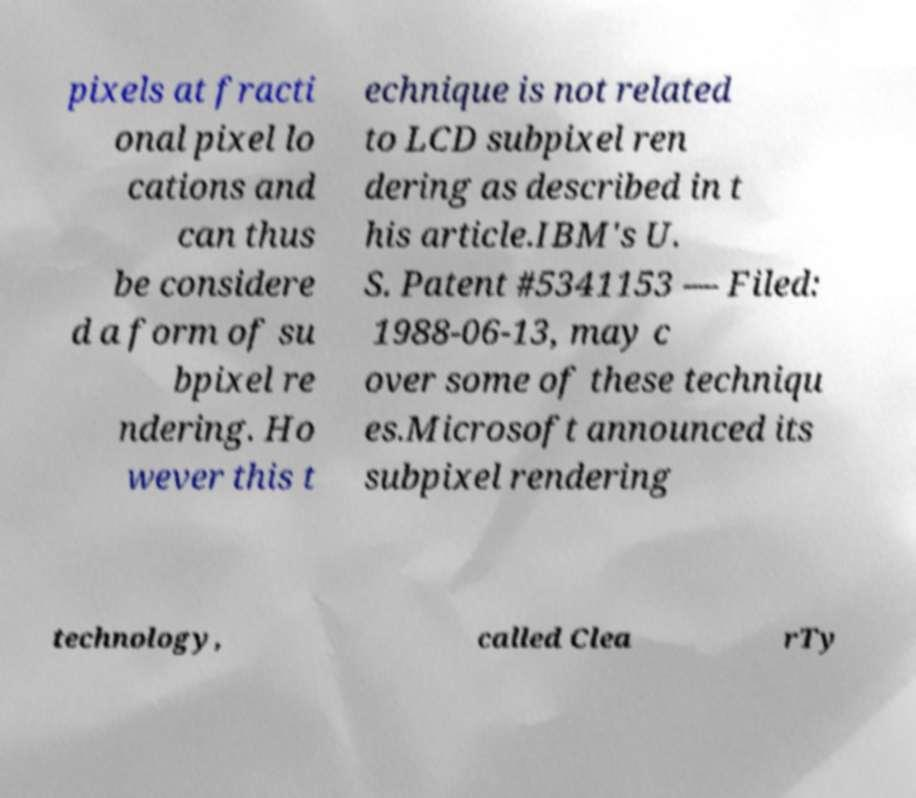Please read and relay the text visible in this image. What does it say? pixels at fracti onal pixel lo cations and can thus be considere d a form of su bpixel re ndering. Ho wever this t echnique is not related to LCD subpixel ren dering as described in t his article.IBM's U. S. Patent #5341153 — Filed: 1988-06-13, may c over some of these techniqu es.Microsoft announced its subpixel rendering technology, called Clea rTy 